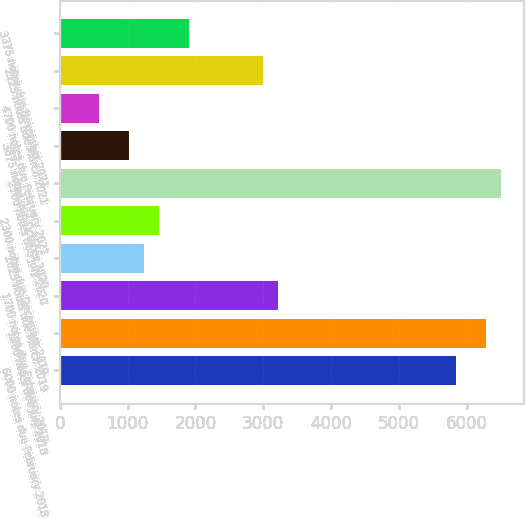Convert chart. <chart><loc_0><loc_0><loc_500><loc_500><bar_chart><fcel>6000 notes due February 2018<fcel>1900 notes due July 2018<fcel>1700 notes due February 2019<fcel>1625 notes due March 2019<fcel>2300 notes due December 2019<fcel>2700 notes due July 2020<fcel>3875 notes due October 2020<fcel>4700 notes due February 2021<fcel>2125 notes due March 2021<fcel>3375 notes due November 2021<nl><fcel>5843.5<fcel>6281.7<fcel>3214.3<fcel>1242.4<fcel>1461.5<fcel>6500.8<fcel>1023.3<fcel>585.1<fcel>2995.2<fcel>1899.7<nl></chart> 